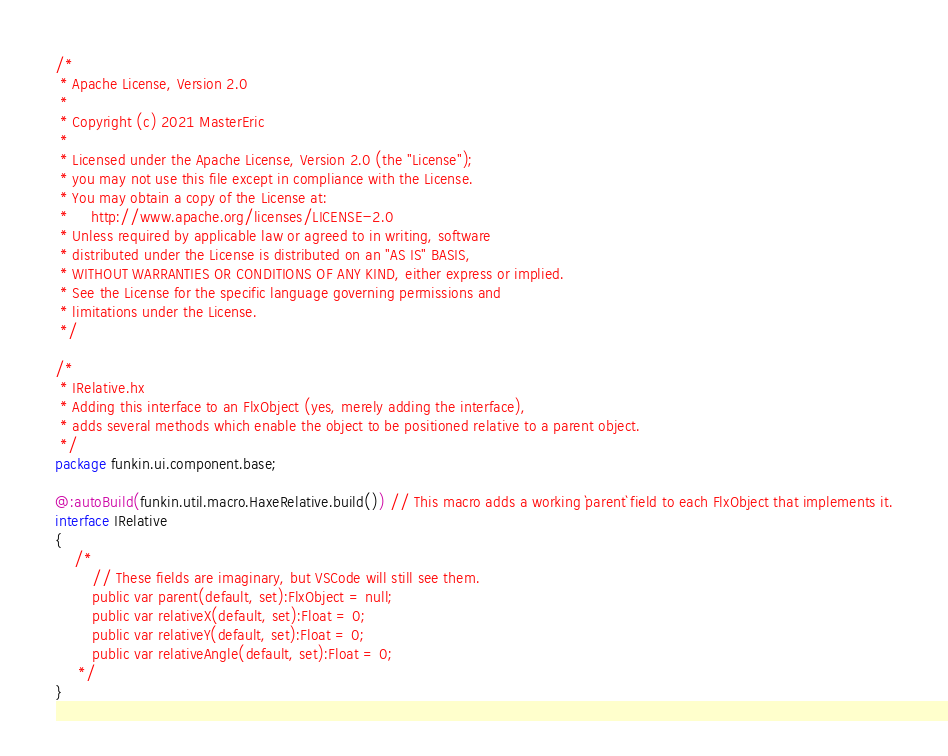<code> <loc_0><loc_0><loc_500><loc_500><_Haxe_>/*
 * Apache License, Version 2.0
 *
 * Copyright (c) 2021 MasterEric
 *
 * Licensed under the Apache License, Version 2.0 (the "License");
 * you may not use this file except in compliance with the License.
 * You may obtain a copy of the License at:
 *     http://www.apache.org/licenses/LICENSE-2.0
 * Unless required by applicable law or agreed to in writing, software
 * distributed under the License is distributed on an "AS IS" BASIS,
 * WITHOUT WARRANTIES OR CONDITIONS OF ANY KIND, either express or implied.
 * See the License for the specific language governing permissions and
 * limitations under the License.
 */

/*
 * IRelative.hx
 * Adding this interface to an FlxObject (yes, merely adding the interface),
 * adds several methods which enable the object to be positioned relative to a parent object.
 */
package funkin.ui.component.base;

@:autoBuild(funkin.util.macro.HaxeRelative.build()) // This macro adds a working `parent` field to each FlxObject that implements it.
interface IRelative
{
	/*
		// These fields are imaginary, but VSCode will still see them.
		public var parent(default, set):FlxObject = null;
		public var relativeX(default, set):Float = 0;
		public var relativeY(default, set):Float = 0;
		public var relativeAngle(default, set):Float = 0;
	 */
}
</code> 